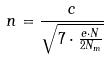Convert formula to latex. <formula><loc_0><loc_0><loc_500><loc_500>n = \frac { c } { \sqrt { 7 \cdot \frac { e \cdot N } { 2 N _ { m } } } }</formula> 